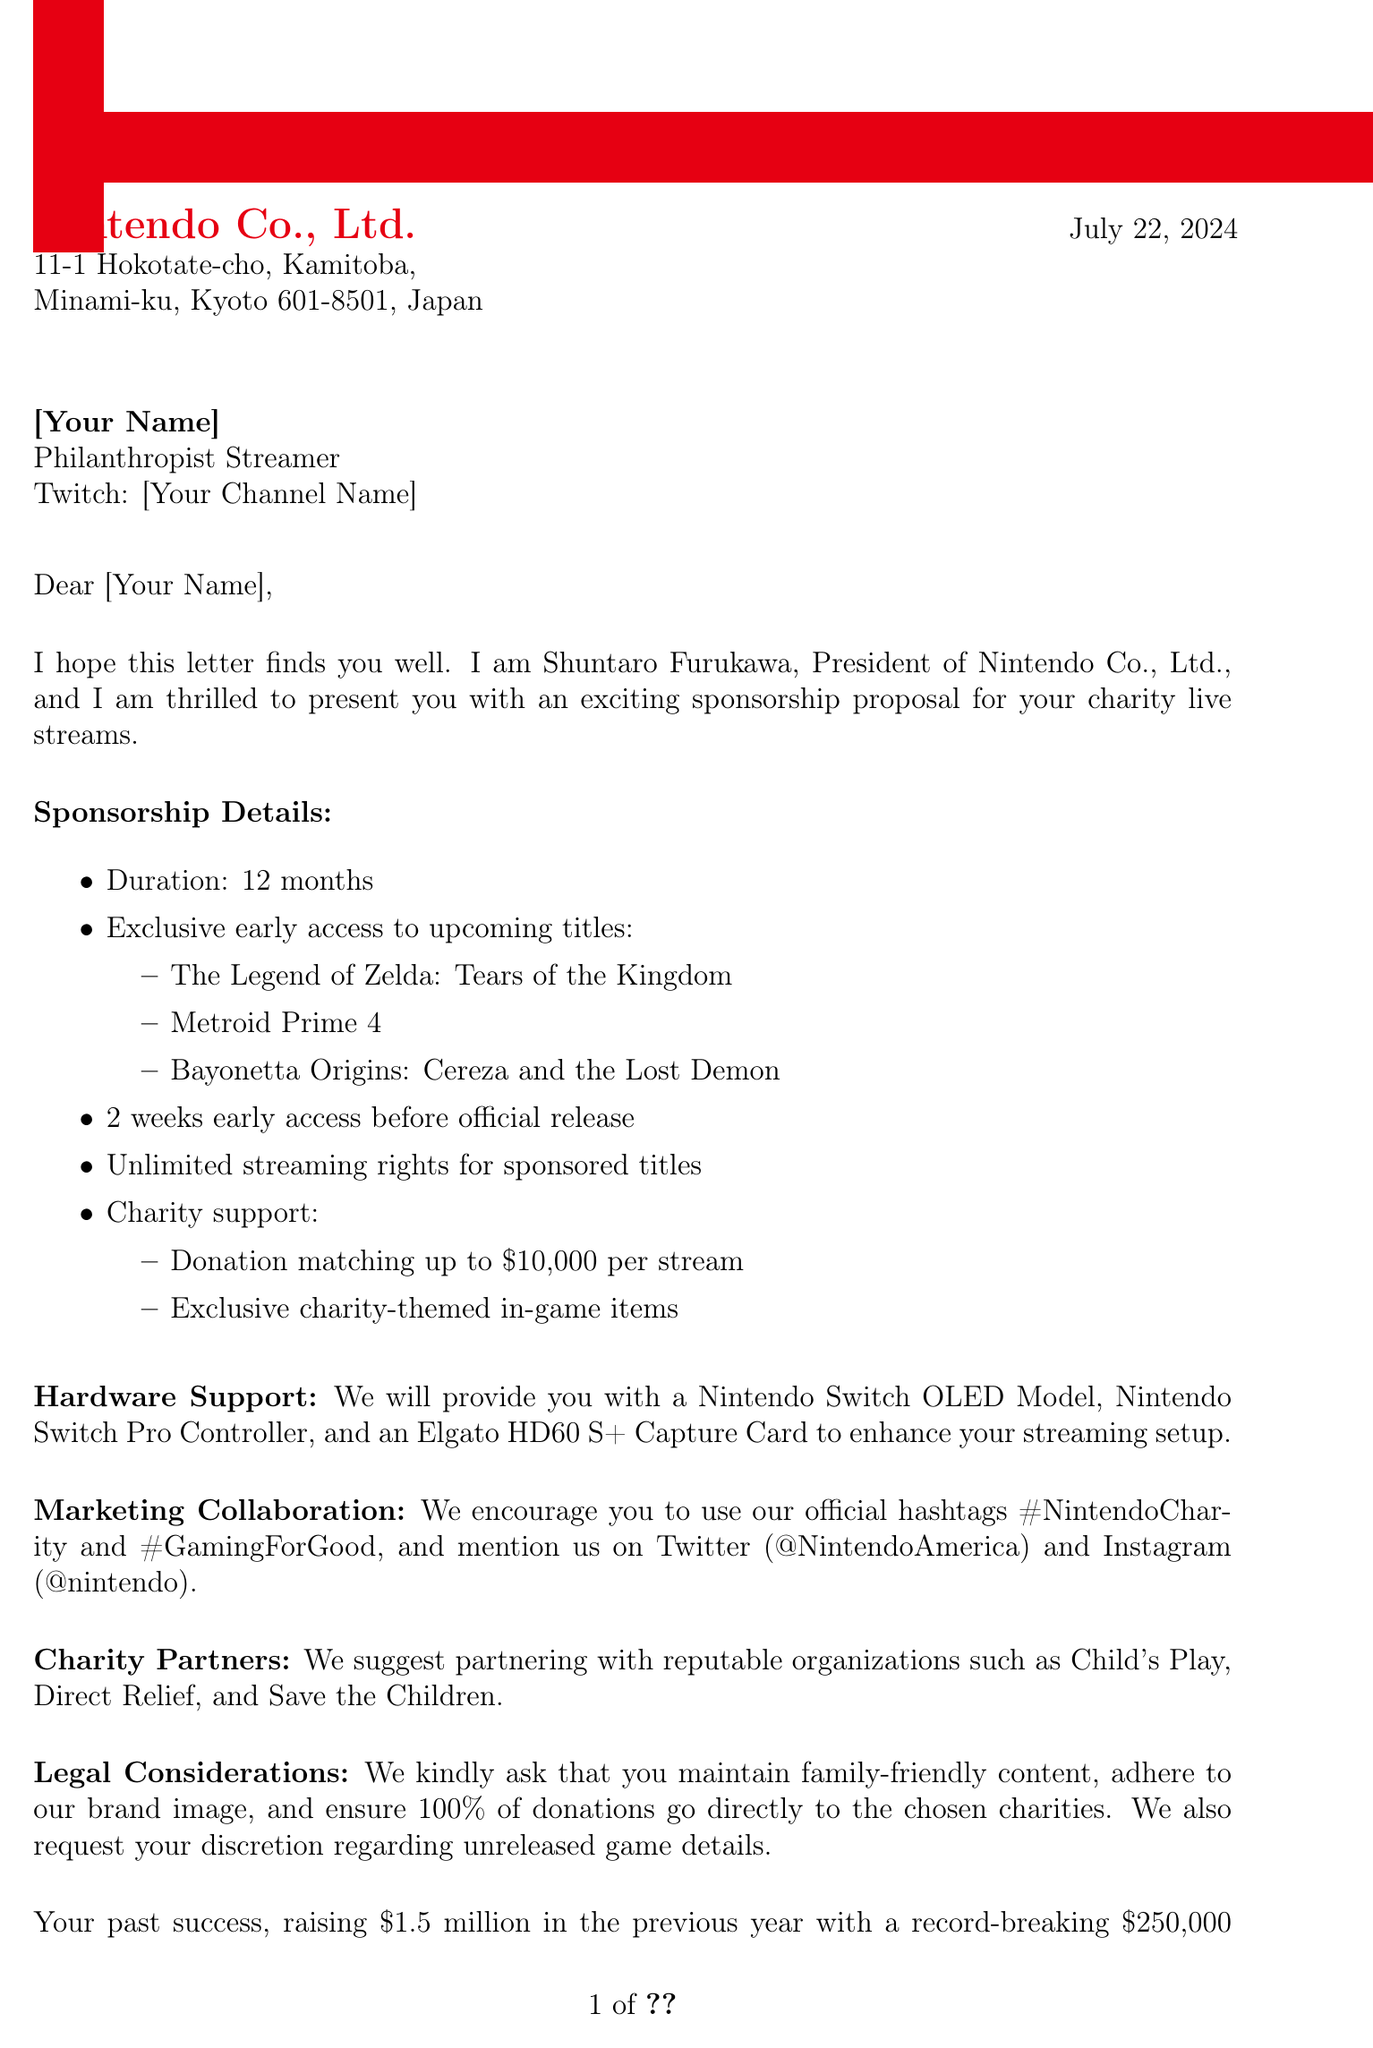What is the duration of the sponsorship? The duration of the sponsorship is explicitly mentioned in the document.
Answer: 12 months Who is the sender of the letter? The sender's name and title are provided in the document.
Answer: Shuntaro Furukawa What is the amount for donation matching per stream? This amount is clearly stated in the charity support section of the document.
Answer: Up to $10,000 Which gaming titles are mentioned for exclusive early access? The document lists the titles under the sponsorship details.
Answer: The Legend of Zelda: Tears of the Kingdom, Metroid Prime 4, Bayonetta Origins: Cereza and the Lost Demon What is the total amount raised last year? This figure is included in the past success metrics section.
Answer: $1.5 million What type of content is required for streaming? This requirement is stated in the legal considerations section of the document.
Answer: Family-friendly streams Who should be contacted for further information? The document specifies the contact person's name and title for any inquiries.
Answer: Eiji Aonuma What is the platform mentioned for the recipient? The platform used by the recipient is detailed in the letter.
Answer: Twitch 